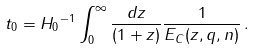Convert formula to latex. <formula><loc_0><loc_0><loc_500><loc_500>t _ { 0 } = { H _ { 0 } } ^ { - 1 } \int _ { 0 } ^ { \infty } \frac { d z } { ( 1 + z ) } \frac { 1 } { E _ { C } ( z , q , n ) } \, .</formula> 